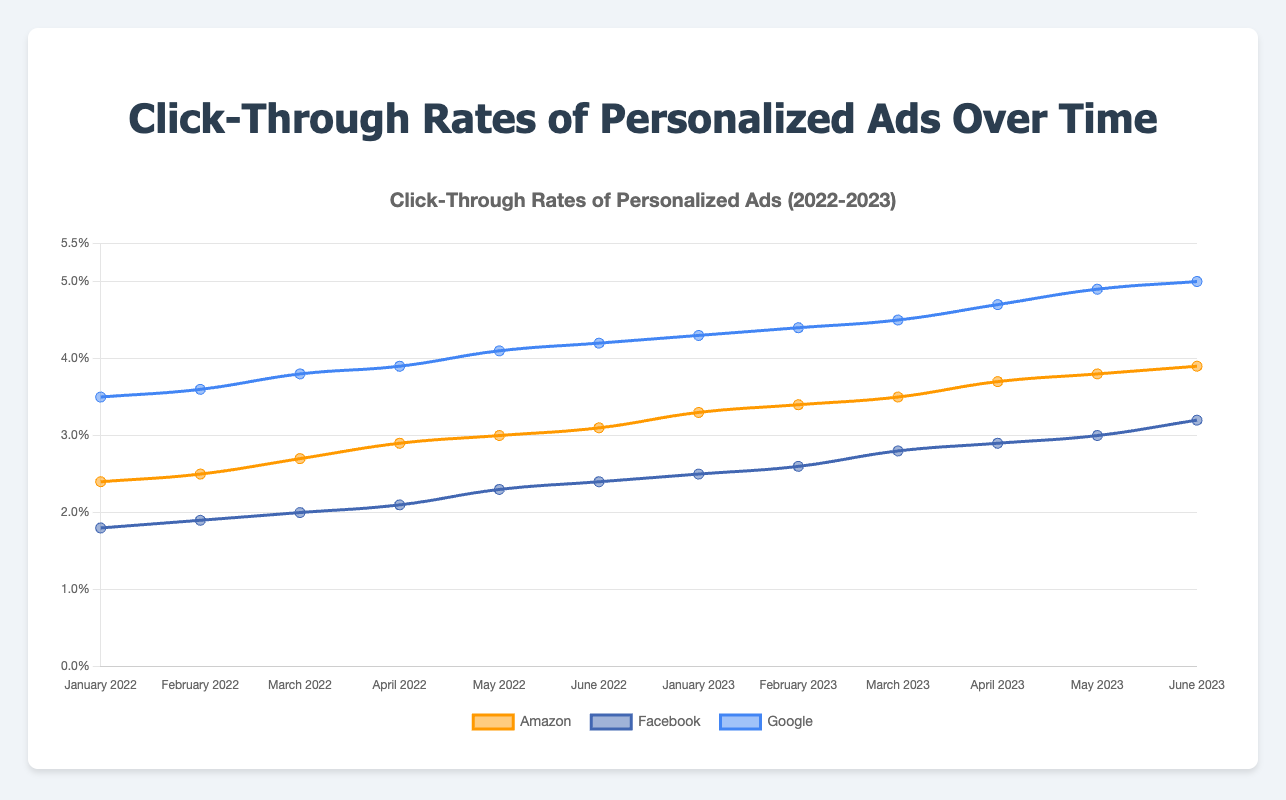What is the Click-Through Rate (CTR) trend for Amazon over the year 2022? The line representing Amazon starts at 2.4% in January 2022 and steadily increases each month, reaching 3.1% by June 2022.
Answer: Increasing trend from 2.4% to 3.1% How does the CTR of Google in June 2022 compare to Facebook in the same month? Google's CTR in June 2022 is 4.2%, while Facebook's is 2.4%.
Answer: Google has a higher CTR What is the average CTR of Facebook across all months in 2023? The CTRs for Facebook in 2023 are 2.5%, 2.6%, 2.8%, 2.9%, 3.0%, and 3.2%. Summing these gives 17.0, and the average is 17.0/6 = 2.83%.
Answer: 2.83% Which company showed the highest CTR at any point in time, and what was the value? Google's CTR in June 2023 reached 5.0%, the highest CTR shown in the figure.
Answer: Google, 5.0% By how much did Amazon's CTR increase from January 2022 to January 2023? Amazon's CTR in January 2022 was 2.4%, and it increased to 3.3% by January 2023. The increment is 3.3% - 2.4% = 0.9%.
Answer: 0.9% Compare the overall changes in CTR for Amazon and Facebook between January 2022 and June 2023. For Amazon, the CTR increased from 2.4% to 3.9%, an increase of 1.5%. For Facebook, the CTR increased from 1.8% to 3.2%, an increase of 1.4%. Both companies showed an increase, with Amazon having a slightly higher change.
Answer: Amazon: +1.5%, Facebook: +1.4% Which company had the smallest fluctuation in CTR during the period from January 2022 to June 2023? To determine fluctuation, look at the difference between the minimum and maximum CTR values for each company. Amazon ranged from 2.4% to 3.9% (1.5%), Facebook ranged from 1.8% to 3.2% (1.4%), Google ranged from 3.5% to 5.0% (1.5%). Thus, Facebook had the smallest fluctuation.
Answer: Facebook How did Google's CTR change from May 2023 to June 2023? Google's CTR increased from 4.9% in May 2023 to 5.0% in June 2023, a change of 0.1%.
Answer: Increased by 0.1% How does Amazon's CTR trend from January 2023 compare to its trend from January 2022? From January 2022 to June 2022, Amazon's CTR steadily increased from 2.4% to 3.1%. From January 2023 to June 2023, the increase continued from 3.3% to 3.9%. Both periods show an increasing trend, but the CTR values are higher in 2023.
Answer: Similar increasing trend 